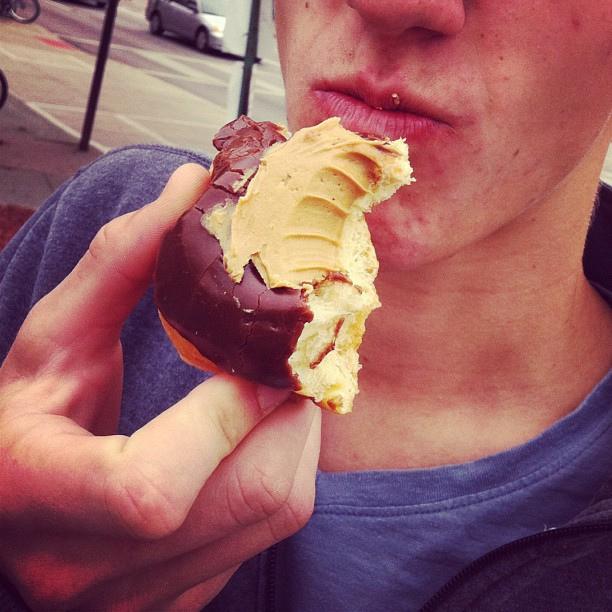Did this man shave recently?
Be succinct. Yes. How many wheels are in the shot?
Be succinct. 3. What is this man eating?
Quick response, please. Donut. 